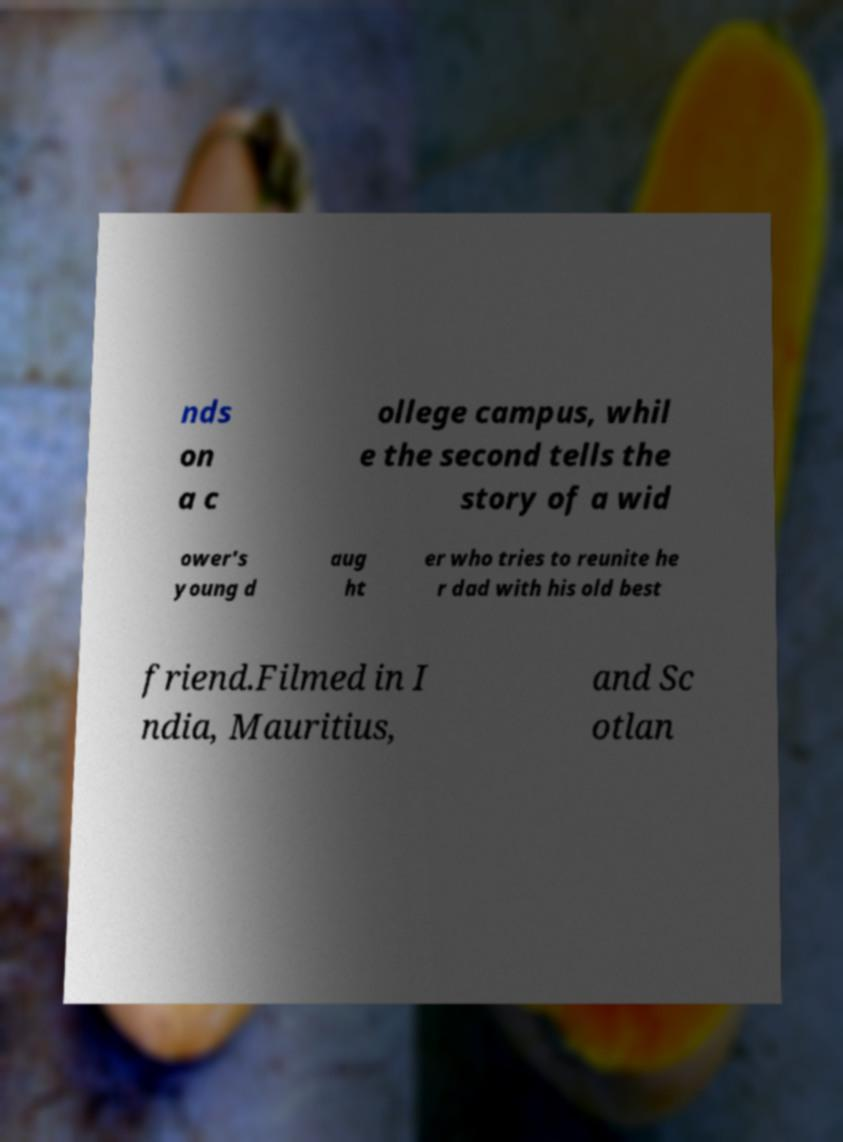Could you extract and type out the text from this image? nds on a c ollege campus, whil e the second tells the story of a wid ower's young d aug ht er who tries to reunite he r dad with his old best friend.Filmed in I ndia, Mauritius, and Sc otlan 